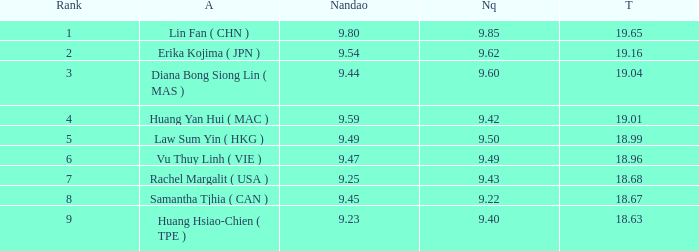Which Nanquan has a Nandao smaller than 9.44, and a Rank smaller than 9, and a Total larger than 18.68? None. 